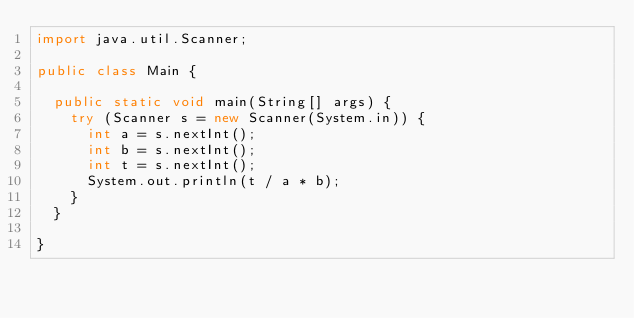Convert code to text. <code><loc_0><loc_0><loc_500><loc_500><_Java_>import java.util.Scanner;

public class Main {

	public static void main(String[] args) {
		try (Scanner s = new Scanner(System.in)) {
			int a = s.nextInt();
			int b = s.nextInt();
			int t = s.nextInt();
			System.out.println(t / a * b);
		}
	}

}
</code> 